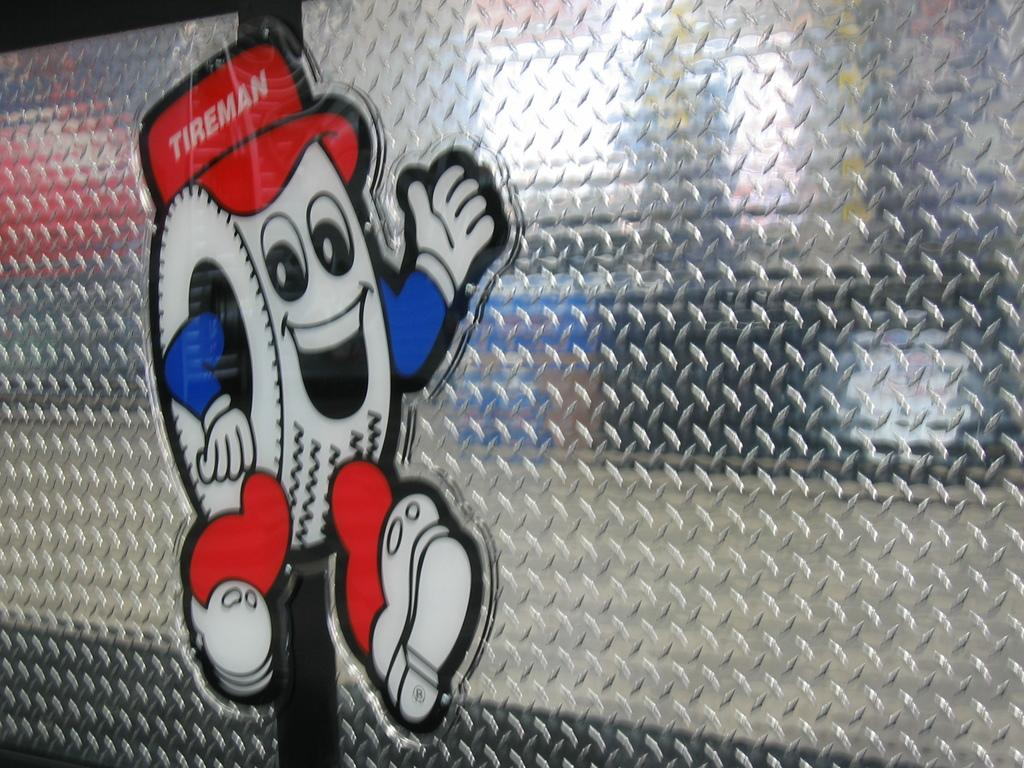What object is present in the image that can hold a liquid? There is a glass in the image that can hold a liquid. What is attached to the glass in the image? There is a sticker on the glass. What colors are present on the sticker? The sticker has white, blue, and red colors. How many books are stacked on the window sill in the image? There are no books or window sill present in the image. 